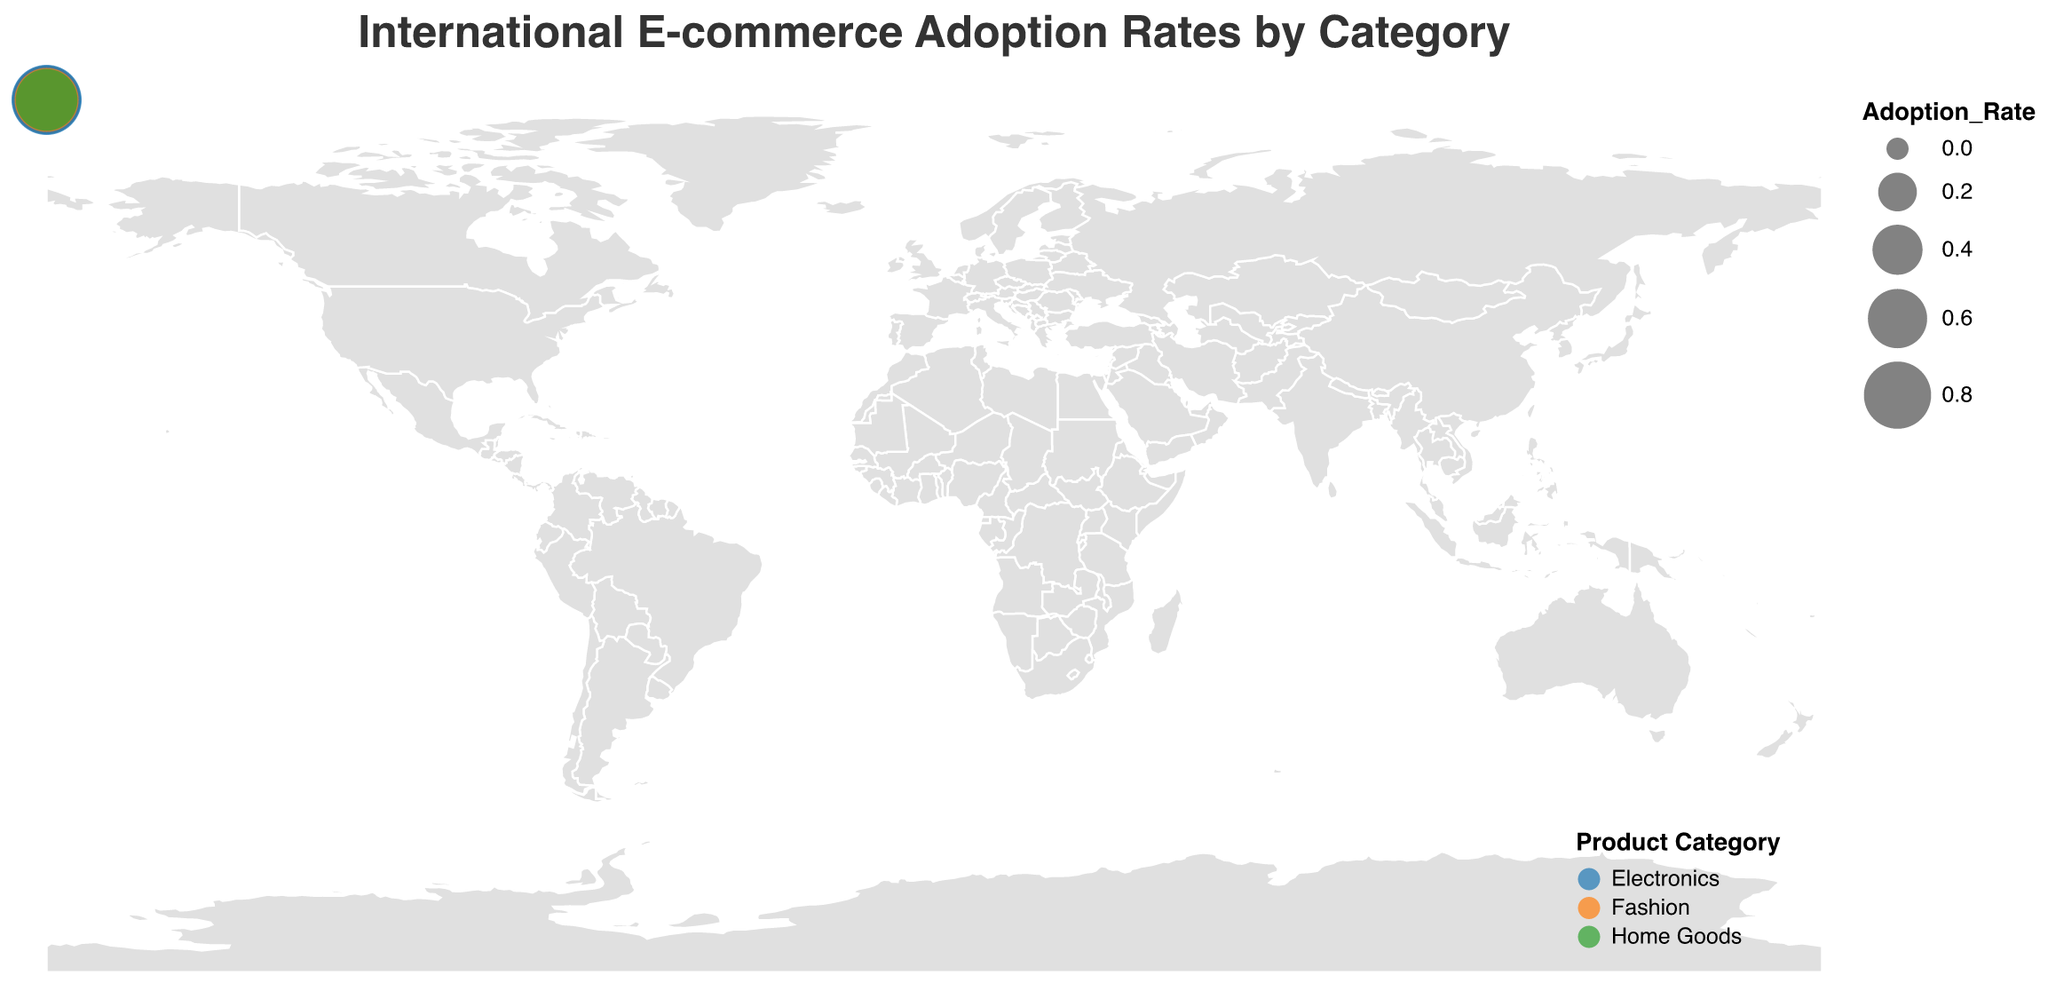What is the title of the figure? The title is positioned at the top of the figure. It states, "International E-commerce Adoption Rates by Category."
Answer: International E-commerce Adoption Rates by Category Which country has the highest adoption rate for Electronics? By looking at the size of the circles and the color code for Electronics, we see that China has the largest circle, indicating the highest adoption rate.
Answer: China Which country shows the lowest adoption rate for Home Goods? By comparing the circle sizes of the Home Goods category across different countries, Brazil has the smallest size, indicating the lowest adoption rate.
Answer: Brazil How much higher is the adoption rate for Fashion in China compared to Japan? Find the adoption rates for Fashion in both countries: China (0.79) and Japan (0.68). Subtract the rate of Japan from China: 0.79 - 0.68 = 0.11
Answer: 0.11 Which product category has the smallest circle size in the United States? By comparing the sizes of the circles color-coded for Electronics, Fashion, and Home Goods in the United States, Home Goods has the smallest circle.
Answer: Home Goods How does Germany's adoption rate for Electronics compare to the United Kingdom's? Germany's adoption rate for Electronics is 0.76, whereas the United Kingdom's is 0.79. Germany's rate is lower by 0.03.
Answer: Lower by 0.03 What is the average adoption rate for Home Goods across all countries? Sum the adoption rates for Home Goods in each country and divide by the number of countries. (0.68 + 0.65 + 0.62 + 0.59 + 0.61 + 0.72 + 0.63 + 0.58 + 0.60 + 0.66) / 10 = 0.634
Answer: 0.63 Which two countries have the closest adoption rates for Fashion? By comparing the adoption rates for Fashion across all countries, France (0.71) and Canada (0.72) have the closest rates with a difference of just 0.01.
Answer: France and Canada In which country is the adoption rate for Electronics significantly higher than for Fashion? Compare adoption rates for Electronics and Fashion across all countries. China shows a significant difference: Electronics (0.88) vs. Fashion (0.79), a difference of 0.09.
Answer: China What is the total adoption rate for Electronics in countries outside of Europe? Sum the adoption rates for Electronics in the non-European countries: United States (0.82) + Japan (0.85) + China (0.88) + Australia (0.77) + Brazil (0.70) + India (0.72) + Canada (0.80) = 5.54
Answer: 5.54 